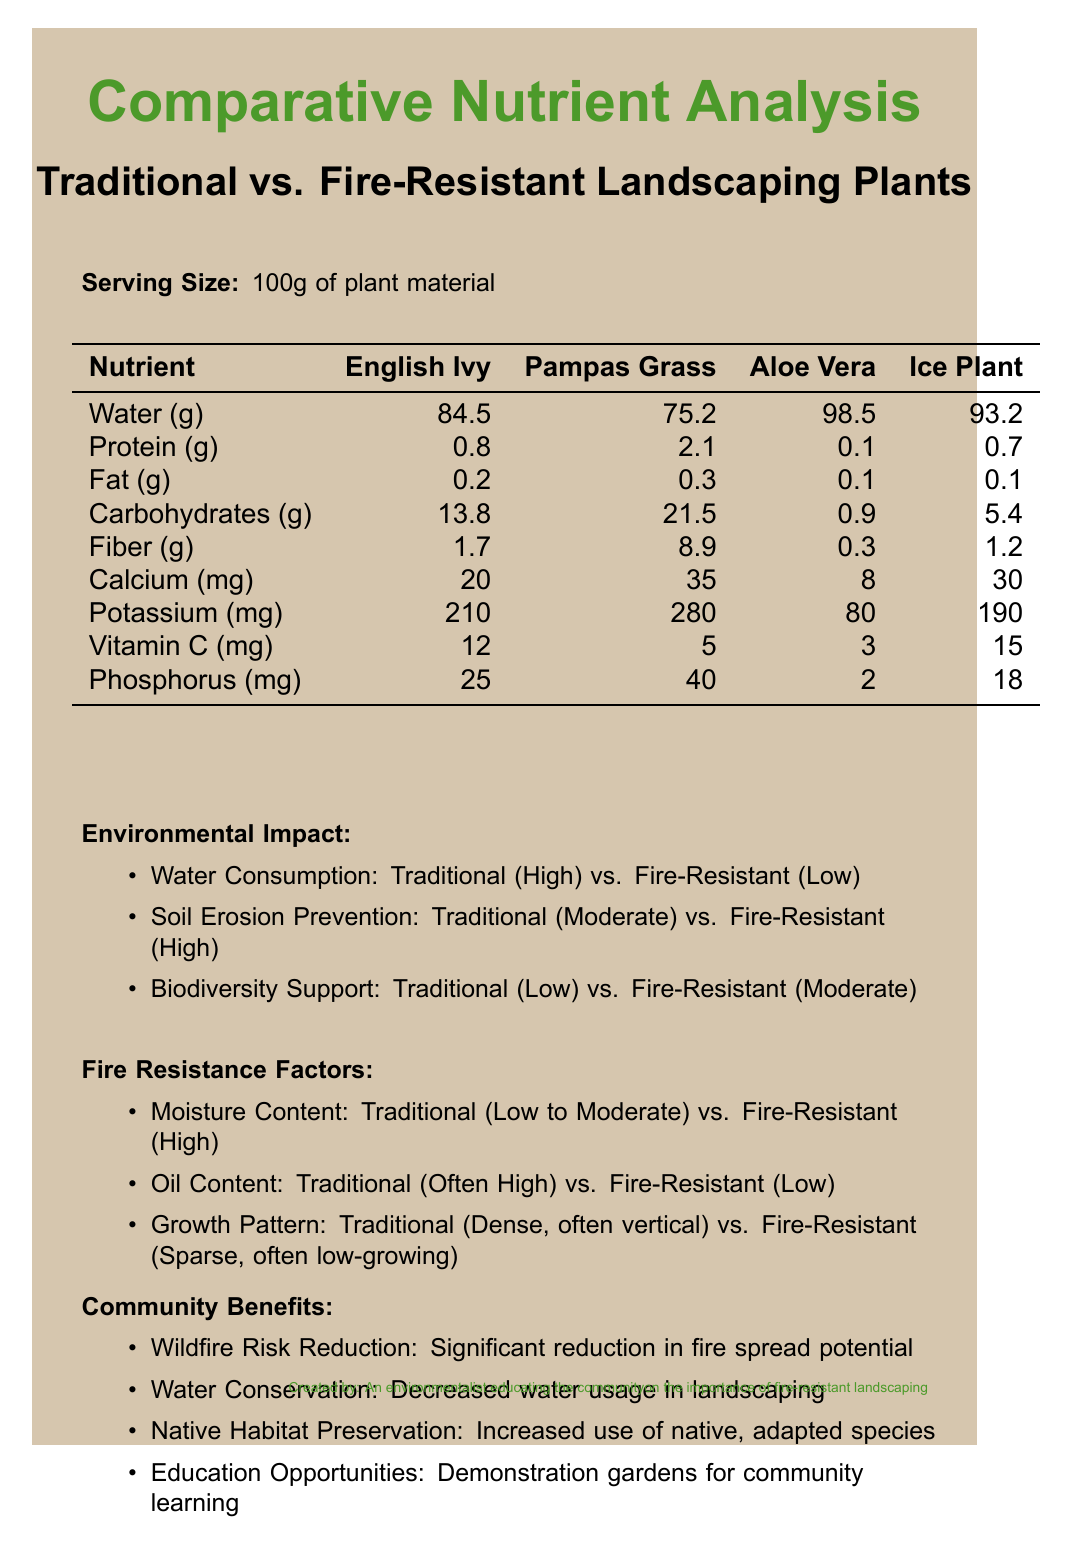what is the serving size for the nutrient analysis? The serving size is explicitly stated as "100g of plant material" in the document.
Answer: 100g of plant material which fire-resistant plant has the highest water content? According to the nutrient table, Aloe Vera contains 98.5g of water per 100g, the highest among the fire-resistant plants.
Answer: Aloe Vera how much protein does Pampas Grass contain? The document lists Pampas Grass as having 2.1g of protein per 100g.
Answer: 2.1g what is the phosphorus content in Ice Plant? The document's nutrient table shows that Ice Plant contains 18mg of phosphorus per 100g.
Answer: 18mg what are some environmental benefits of using fire-resistant plants? Listed in the Environmental Impact section, fire-resistant plants offer lower water consumption, better soil erosion prevention, and moderate support for biodiversity.
Answer: Reduced water consumption, prevention of soil erosion, and support for biodiversity which traditional plant provides the most carbohydrates? A. English Ivy B. Pampas Grass C. Neither of these The nutrient table shows that Pampas Grass has 21.5g of carbohydrates, more than English Ivy, which has 13.8g.
Answer: B. Pampas Grass which plant has the lowest potassium content? 1. English Ivy 2. Pampas Grass 3. Aloe Vera 4. Ice Plant Aloe Vera contains 80mg of potassium, the lowest among the plants listed.
Answer: 3. Aloe Vera is the oil content in fire-resistant plants typically high? The document states that fire-resistant plants have low oil content, while traditional plants often have high oil content.
Answer: No does the use of fire-resistant plants contribute to wildfire risk reduction? One of the community benefits listed is a significant reduction in fire spread potential.
Answer: Yes describe the main idea of the document The document provides a comprehensive overview of how fire-resistant plants differ from traditional plants in nutrient content, environmental impact, and fire resistance, emphasizing the advantages of using fire-resistant plants for community safety and sustainability.
Answer: The document compares the nutrients, environmental impacts, and fire resistance factors of traditional and fire-resistant landscaping plants. It highlights the benefits of fire-resistant plants in terms of wildfire risk reduction, water conservation, and support for native habitats. which plant's moisture content is highest? The document lists moisture content categories (low to moderate for traditional, high for fire-resistant) but doesn't provide specific numerical values to determine which exact plant has the highest moisture.
Answer: Not enough information how does traditional landscaping fare in terms of biodiversity support compared to fire-resistant landscaping? According to the environmental impact section, traditional plants support low biodiversity, whereas fire-resistant plants support moderate biodiversity.
Answer: Traditional landscaping provides low biodiversity support, while fire-resistant landscaping provides moderate support what is the primary function of using demonstration gardens as part of community benefits? The document lists demonstration gardens specifically under education opportunities to help the community learn about fire-resistant landscaping.
Answer: Education opportunities 